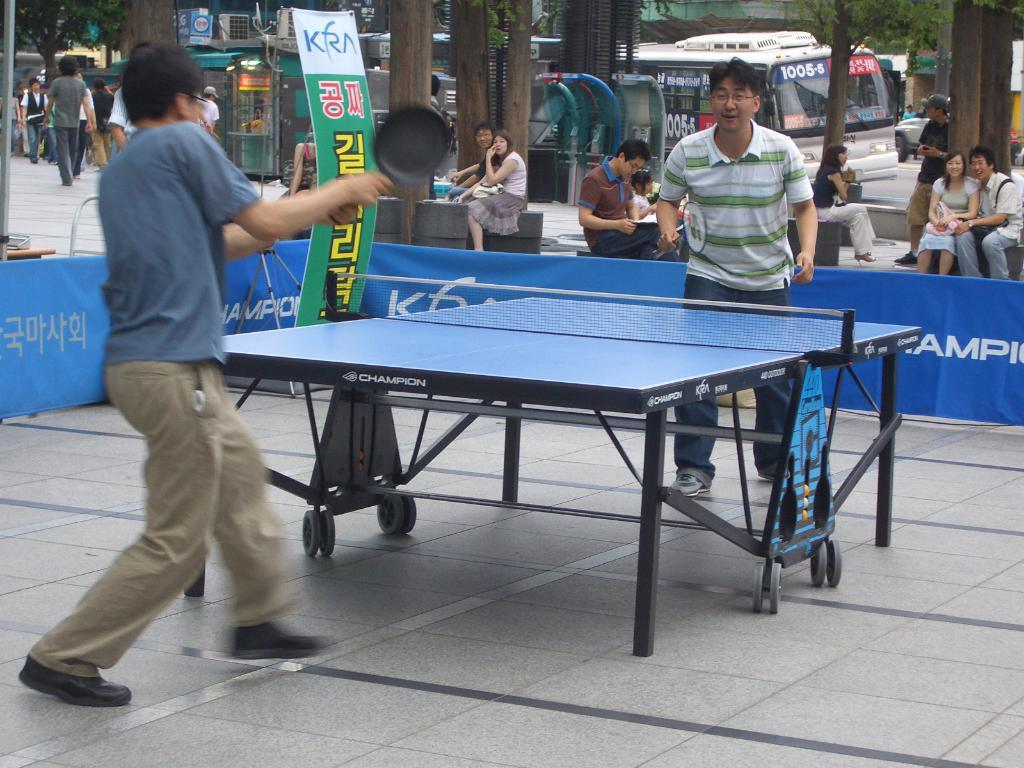What activity are the persons in the image engaged in? Two persons are playing table tennis in the image. Can you describe the other persons in the image? There are persons sitting and walking in the background of the image. How many persons are playing table tennis? Two persons are playing table tennis. What type of fold can be seen in the image? There is no fold present in the image. What kind of camera is being used to capture the image? The question assumes that the image is being captured by a camera, but the facts provided do not mention a camera. 